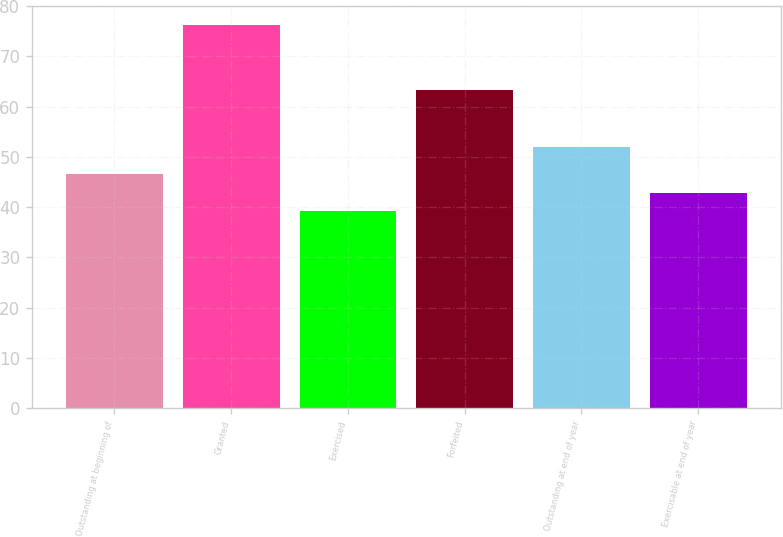<chart> <loc_0><loc_0><loc_500><loc_500><bar_chart><fcel>Outstanding at beginning of<fcel>Granted<fcel>Exercised<fcel>Forfeited<fcel>Outstanding at end of year<fcel>Exercisable at end of year<nl><fcel>46.56<fcel>76.21<fcel>39.14<fcel>63.27<fcel>51.96<fcel>42.85<nl></chart> 